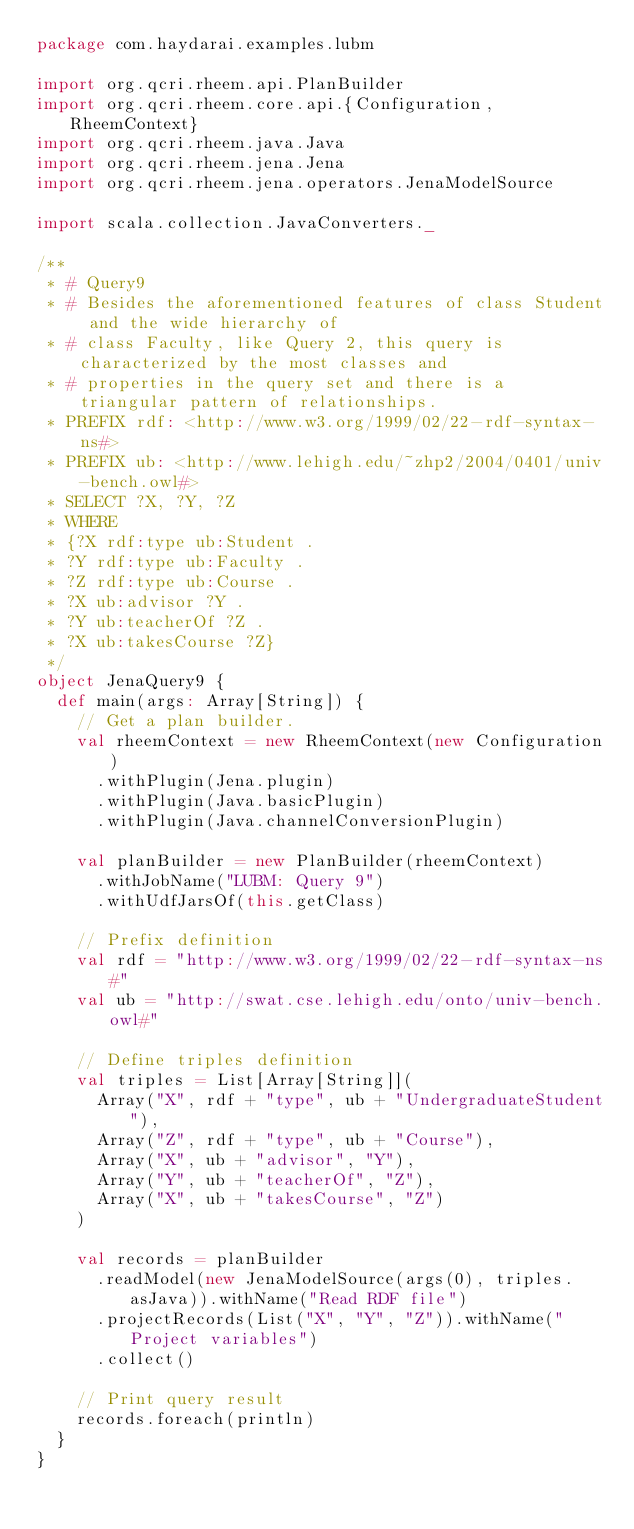Convert code to text. <code><loc_0><loc_0><loc_500><loc_500><_Scala_>package com.haydarai.examples.lubm

import org.qcri.rheem.api.PlanBuilder
import org.qcri.rheem.core.api.{Configuration, RheemContext}
import org.qcri.rheem.java.Java
import org.qcri.rheem.jena.Jena
import org.qcri.rheem.jena.operators.JenaModelSource

import scala.collection.JavaConverters._

/**
 * # Query9
 * # Besides the aforementioned features of class Student and the wide hierarchy of
 * # class Faculty, like Query 2, this query is characterized by the most classes and
 * # properties in the query set and there is a triangular pattern of relationships.
 * PREFIX rdf: <http://www.w3.org/1999/02/22-rdf-syntax-ns#>
 * PREFIX ub: <http://www.lehigh.edu/~zhp2/2004/0401/univ-bench.owl#>
 * SELECT ?X, ?Y, ?Z
 * WHERE
 * {?X rdf:type ub:Student .
 * ?Y rdf:type ub:Faculty .
 * ?Z rdf:type ub:Course .
 * ?X ub:advisor ?Y .
 * ?Y ub:teacherOf ?Z .
 * ?X ub:takesCourse ?Z}
 */
object JenaQuery9 {
  def main(args: Array[String]) {
    // Get a plan builder.
    val rheemContext = new RheemContext(new Configuration)
      .withPlugin(Jena.plugin)
      .withPlugin(Java.basicPlugin)
      .withPlugin(Java.channelConversionPlugin)

    val planBuilder = new PlanBuilder(rheemContext)
      .withJobName("LUBM: Query 9")
      .withUdfJarsOf(this.getClass)

    // Prefix definition
    val rdf = "http://www.w3.org/1999/02/22-rdf-syntax-ns#"
    val ub = "http://swat.cse.lehigh.edu/onto/univ-bench.owl#"

    // Define triples definition
    val triples = List[Array[String]](
      Array("X", rdf + "type", ub + "UndergraduateStudent"),
      Array("Z", rdf + "type", ub + "Course"),
      Array("X", ub + "advisor", "Y"),
      Array("Y", ub + "teacherOf", "Z"),
      Array("X", ub + "takesCourse", "Z")
    )

    val records = planBuilder
      .readModel(new JenaModelSource(args(0), triples.asJava)).withName("Read RDF file")
      .projectRecords(List("X", "Y", "Z")).withName("Project variables")
      .collect()

    // Print query result
    records.foreach(println)
  }
}
</code> 